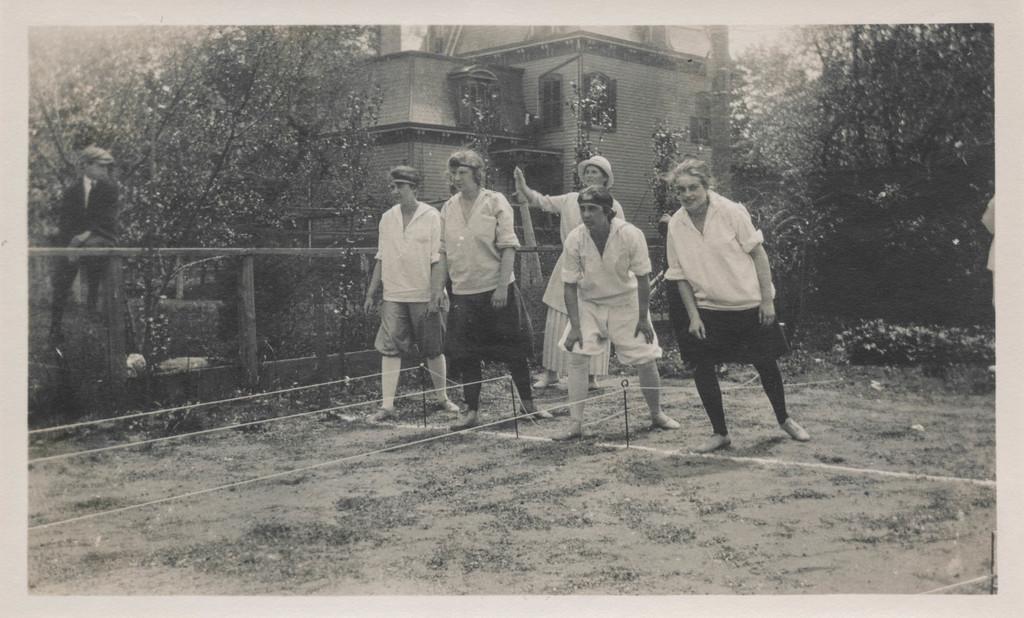Could you give a brief overview of what you see in this image? In this image there are people standing. On the left side a boy is sitting. There is sand. There are trees. There is a building. 